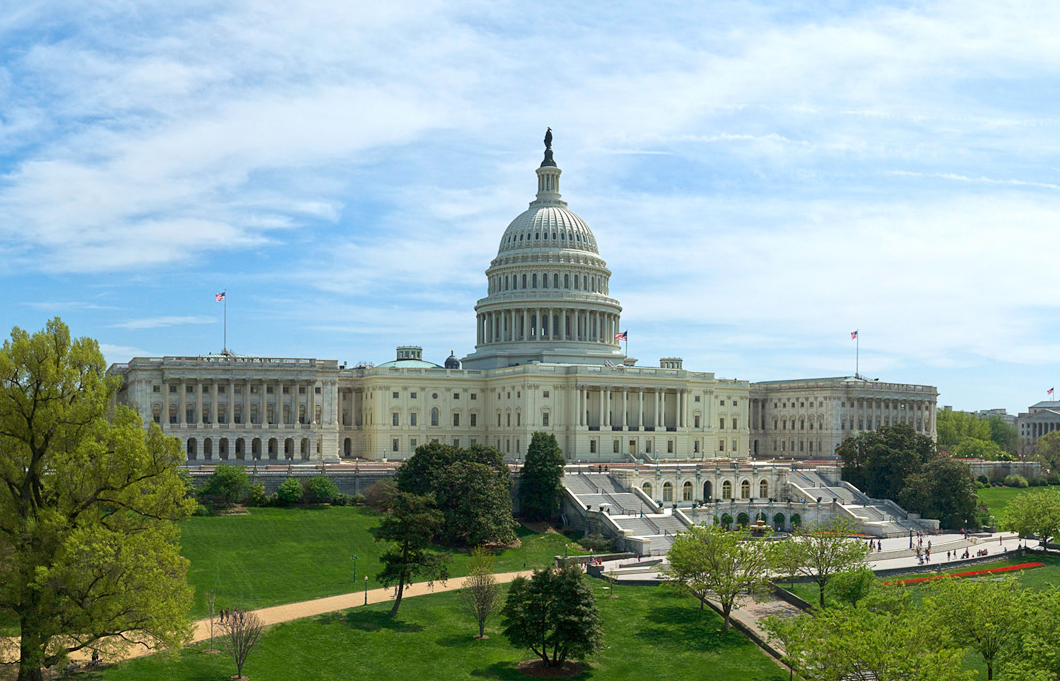Can you tell me about any notable architectural features visible in this image of the Capitol? Certainly! The Capitol's design is an exceptional example of the American Neoclassical style, strongly influenced by ancient Greek and Roman architecture. Prominent in the image is the Capitol's dome, constructed of cast iron and designed by Thomas U. Walter, crowned by the Statue of Freedom. The East Front, which you see, features a central portico that is an iconic spot for presidential inaugurations. Additionally, the building showcases numerous pilasters, balustrades, and intricate reliefs that enhance its grandeur. 